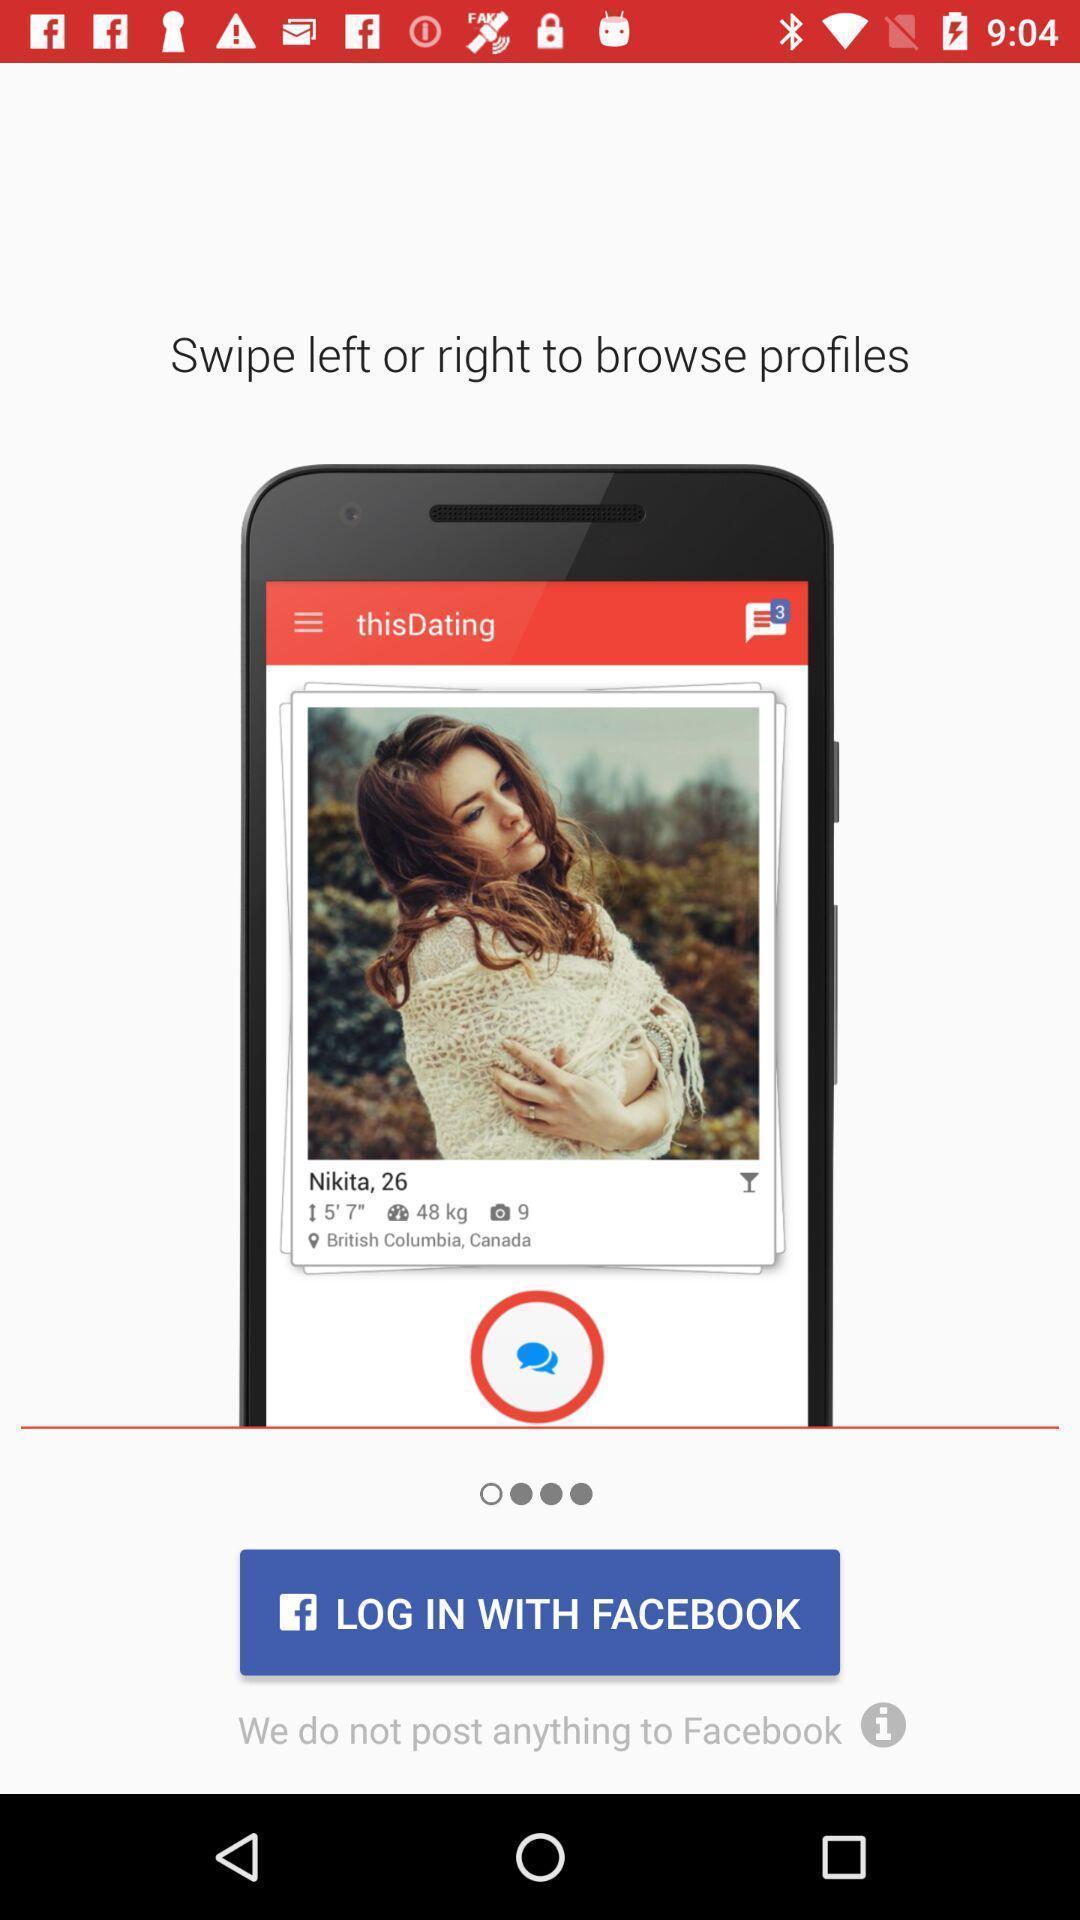Provide a detailed account of this screenshot. Page shows to login with the social app. 